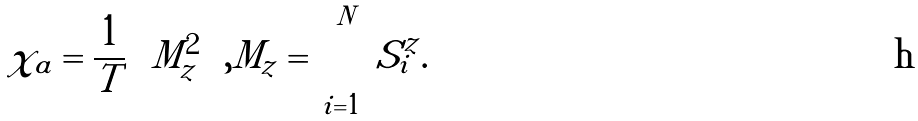Convert formula to latex. <formula><loc_0><loc_0><loc_500><loc_500>\chi _ { a } = \frac { 1 } { T } \left \langle M _ { z } ^ { 2 } \right \rangle , M _ { z } = \sum _ { i = 1 } ^ { N } S ^ { z } _ { i } .</formula> 